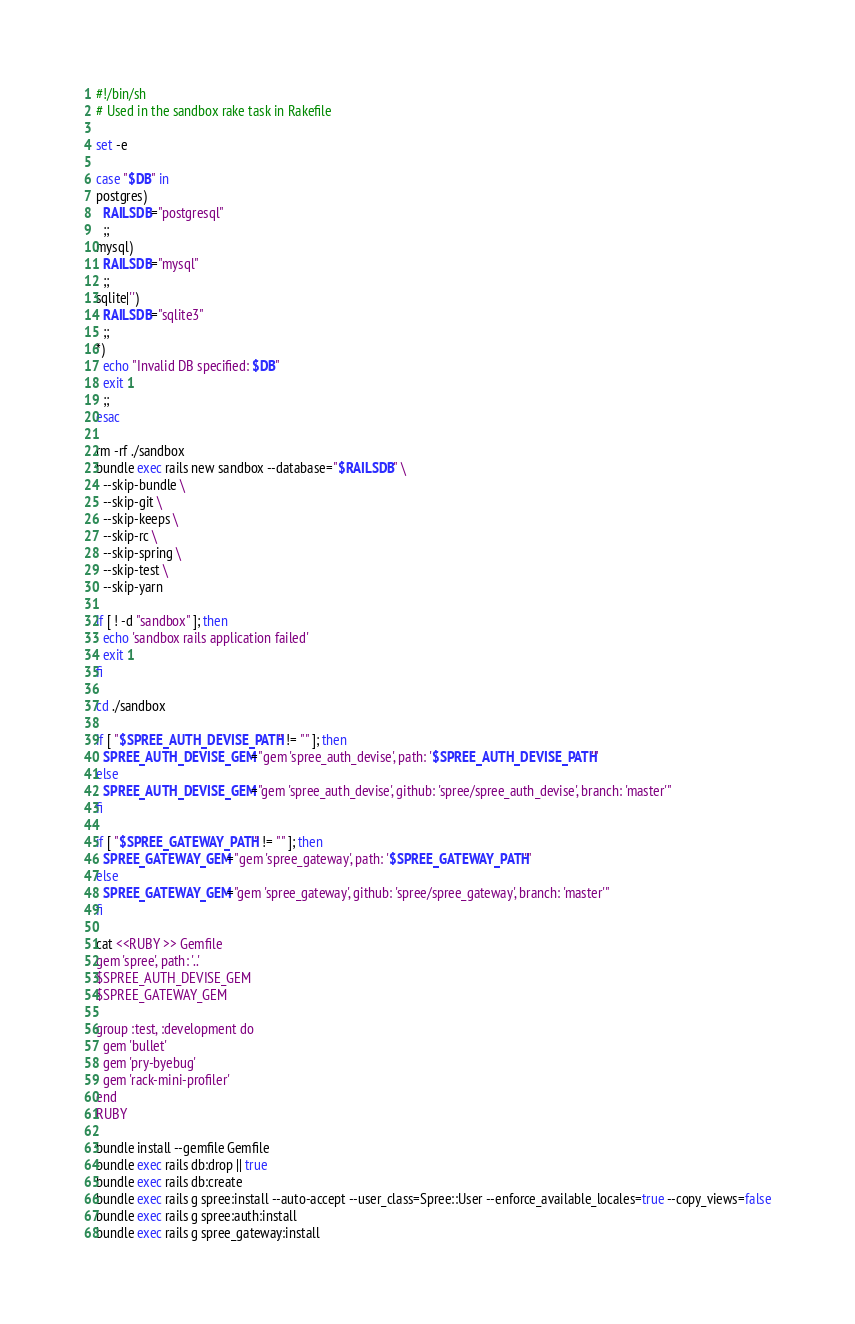Convert code to text. <code><loc_0><loc_0><loc_500><loc_500><_Bash_>#!/bin/sh
# Used in the sandbox rake task in Rakefile

set -e

case "$DB" in
postgres)
  RAILSDB="postgresql"
  ;;
mysql)
  RAILSDB="mysql"
  ;;
sqlite|'')
  RAILSDB="sqlite3"
  ;;
*)
  echo "Invalid DB specified: $DB"
  exit 1
  ;;
esac

rm -rf ./sandbox
bundle exec rails new sandbox --database="$RAILSDB" \
  --skip-bundle \
  --skip-git \
  --skip-keeps \
  --skip-rc \
  --skip-spring \
  --skip-test \
  --skip-yarn

if [ ! -d "sandbox" ]; then
  echo 'sandbox rails application failed'
  exit 1
fi

cd ./sandbox

if [ "$SPREE_AUTH_DEVISE_PATH" != "" ]; then
  SPREE_AUTH_DEVISE_GEM="gem 'spree_auth_devise', path: '$SPREE_AUTH_DEVISE_PATH'"
else
  SPREE_AUTH_DEVISE_GEM="gem 'spree_auth_devise', github: 'spree/spree_auth_devise', branch: 'master'"
fi

if [ "$SPREE_GATEWAY_PATH" != "" ]; then
  SPREE_GATEWAY_GEM="gem 'spree_gateway', path: '$SPREE_GATEWAY_PATH'"
else
  SPREE_GATEWAY_GEM="gem 'spree_gateway', github: 'spree/spree_gateway', branch: 'master'"
fi

cat <<RUBY >> Gemfile
gem 'spree', path: '..'
$SPREE_AUTH_DEVISE_GEM
$SPREE_GATEWAY_GEM

group :test, :development do
  gem 'bullet'
  gem 'pry-byebug'
  gem 'rack-mini-profiler'
end
RUBY

bundle install --gemfile Gemfile
bundle exec rails db:drop || true
bundle exec rails db:create
bundle exec rails g spree:install --auto-accept --user_class=Spree::User --enforce_available_locales=true --copy_views=false
bundle exec rails g spree:auth:install
bundle exec rails g spree_gateway:install
</code> 